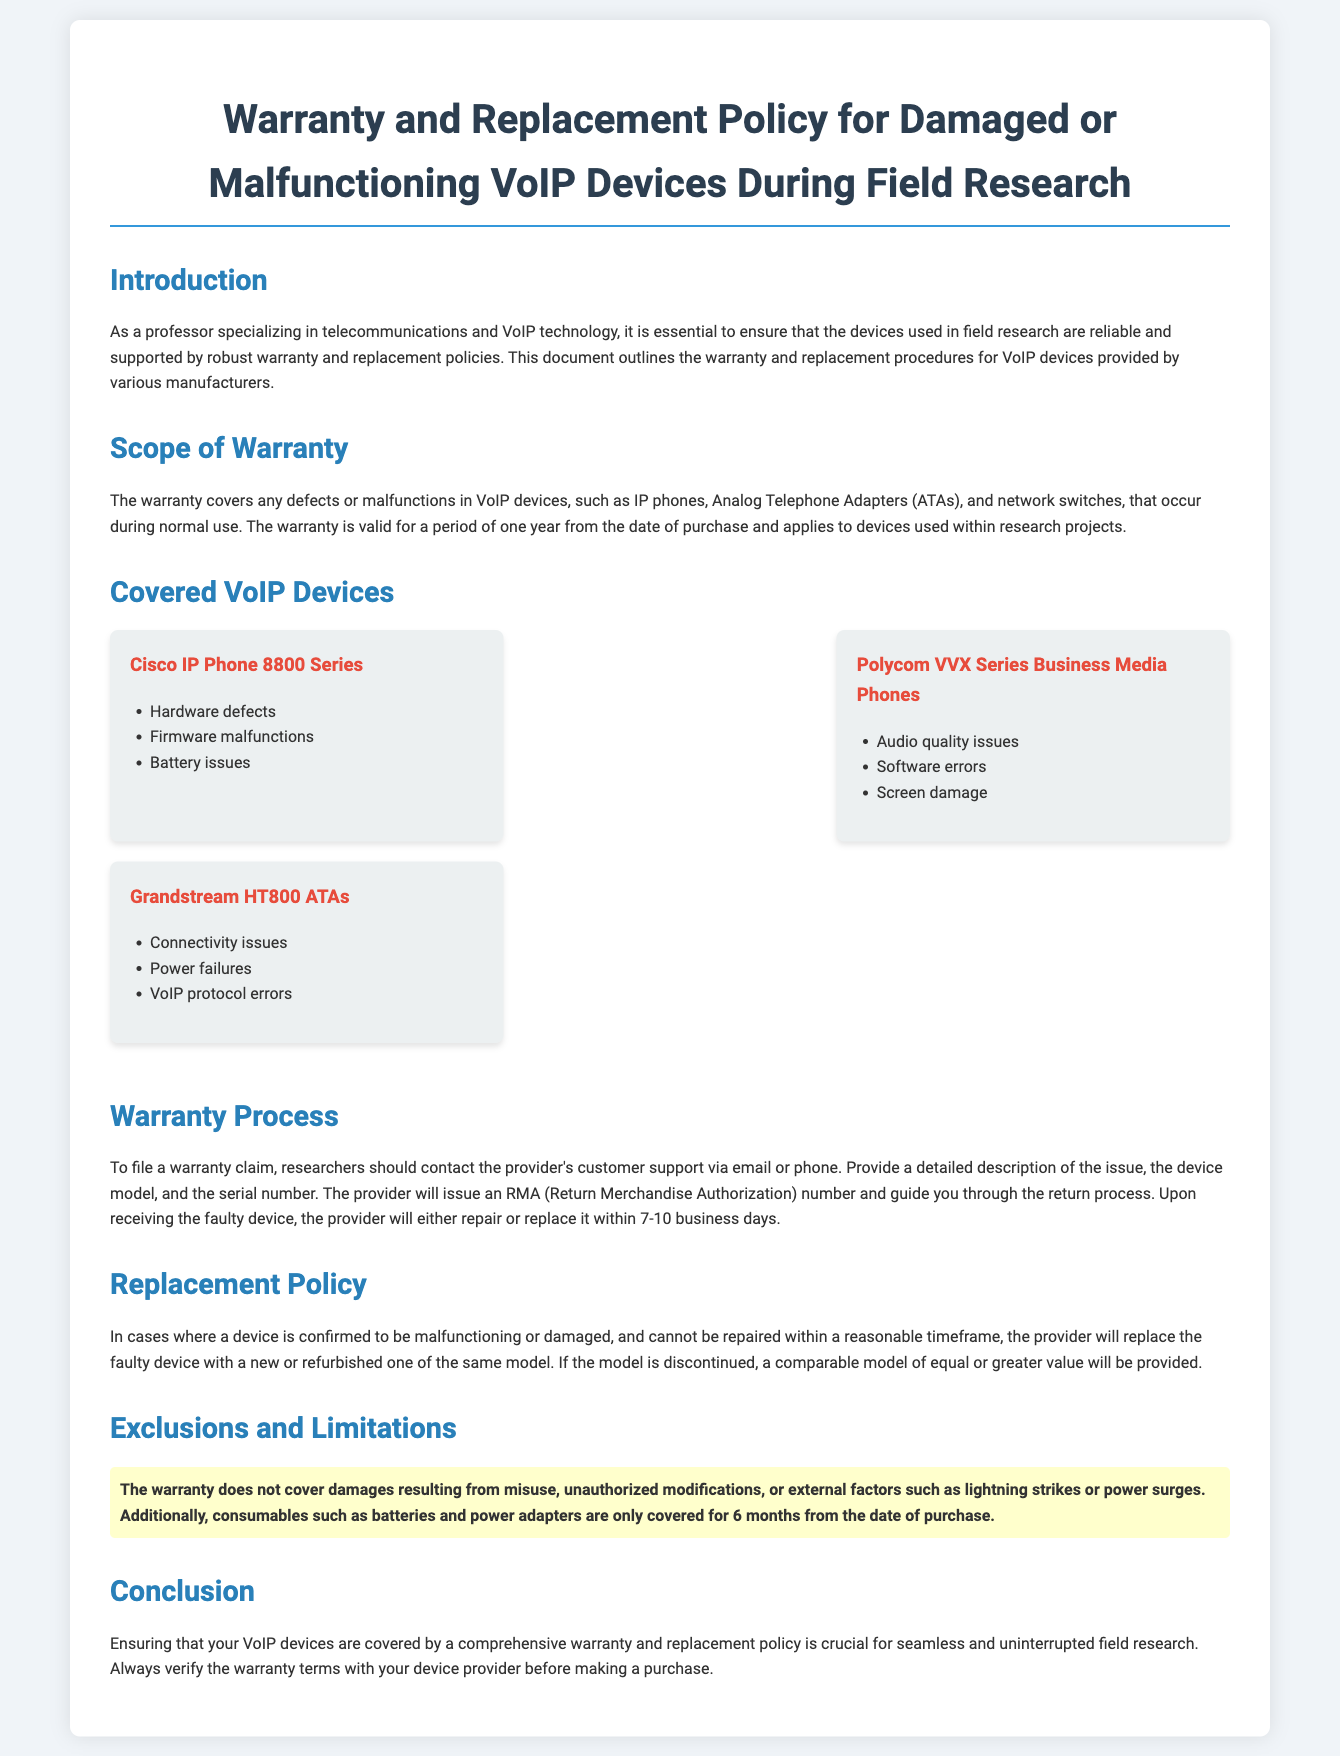What is the duration of the warranty? The warranty is valid for a period of one year from the date of purchase.
Answer: One year What types of devices are covered under the warranty? The warranty covers IP phones, Analog Telephone Adapters, and network switches.
Answer: IP phones, ATAs, network switches How long does the provider take to repair or replace a device? The provider will repair or replace the device within 7-10 business days.
Answer: 7-10 business days What is required to file a warranty claim? Researchers should provide a detailed description of the issue, device model, and serial number.
Answer: Detailed description, device model, serial number What will be provided if a discontinued model is claimed? A comparable model of equal or greater value will be provided.
Answer: Comparable model What is not covered by the warranty? The warranty does not cover damages resulting from misuse, unauthorized modifications, or external factors.
Answer: Misuse, unauthorized modifications, external factors How long are consumables like batteries covered? Consumables such as batteries are only covered for 6 months from the date of purchase.
Answer: 6 months What action must be taken after contacting customer support for warranty claims? The provider will issue an RMA number and guide you through the return process.
Answer: Issue an RMA number 